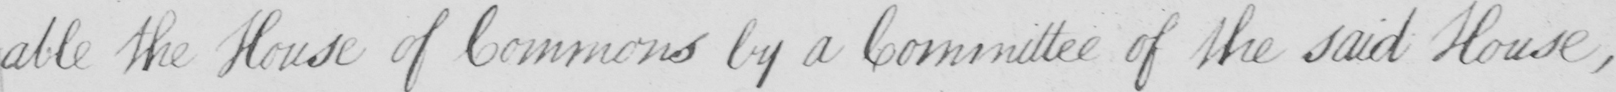Can you read and transcribe this handwriting? -able the House of Commons by a Committee of the said House , 